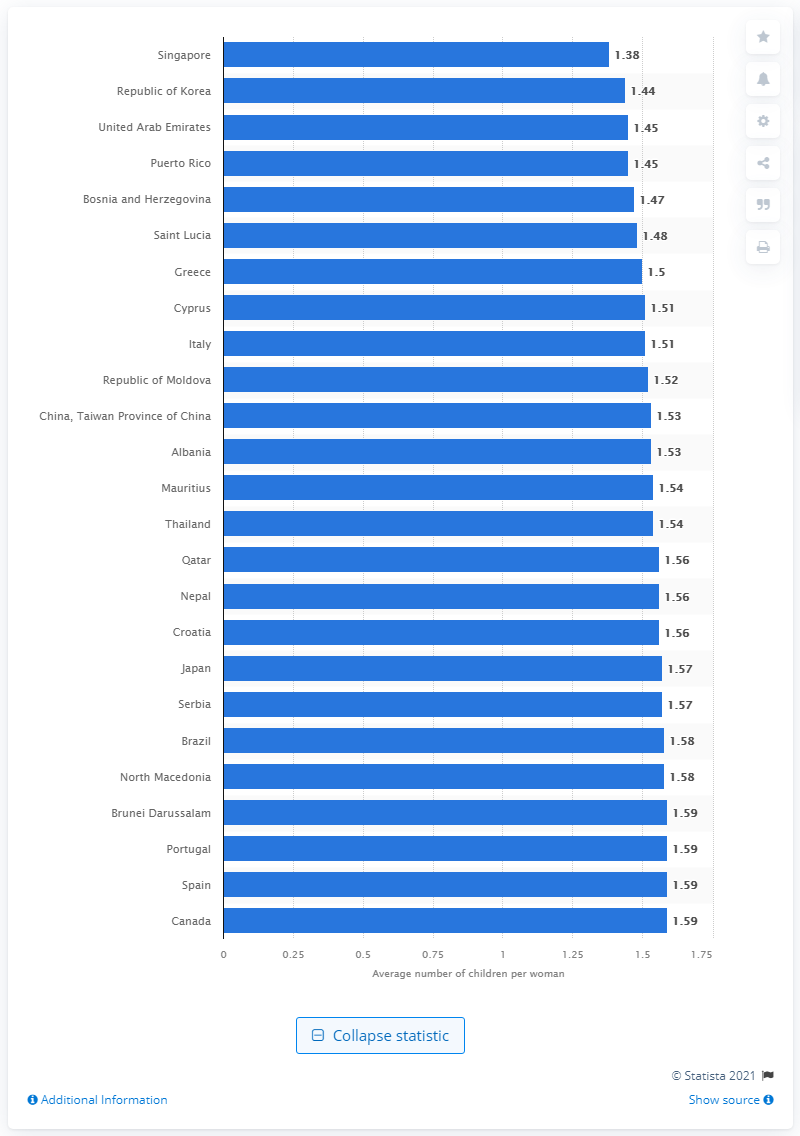Draw attention to some important aspects in this diagram. According to projections, Singapore's average fertility rate between 2050 and 2055 is expected to be 1.38. 